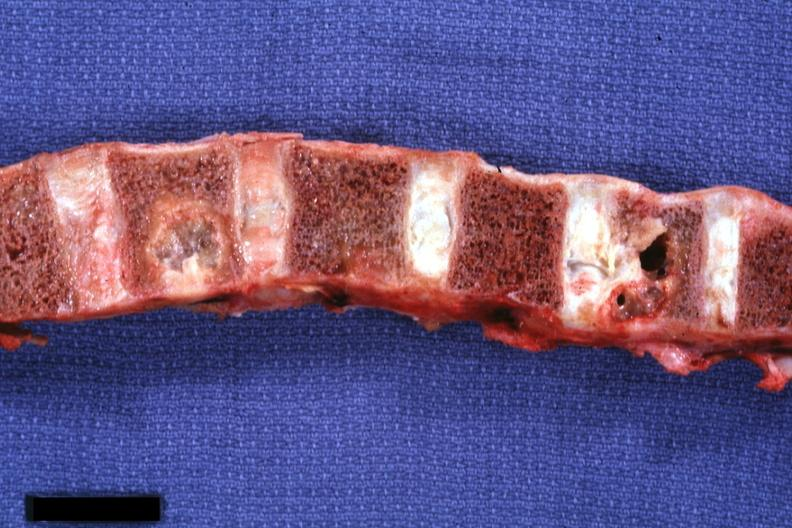does this image show vertebral column with well shown gross lesions?
Answer the question using a single word or phrase. Yes 